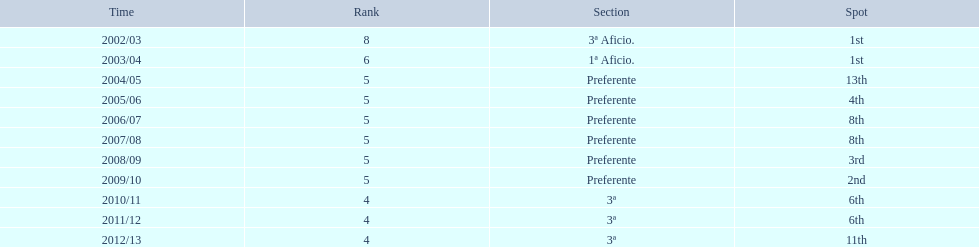How many years was the team in the 3 a division? 4. 